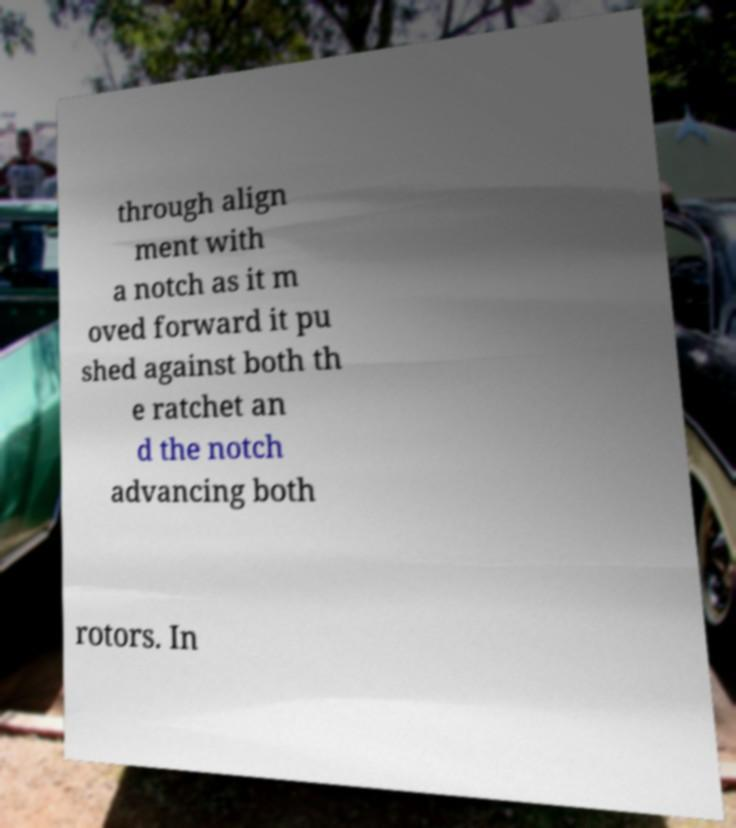Can you read and provide the text displayed in the image?This photo seems to have some interesting text. Can you extract and type it out for me? through align ment with a notch as it m oved forward it pu shed against both th e ratchet an d the notch advancing both rotors. In 